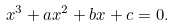Convert formula to latex. <formula><loc_0><loc_0><loc_500><loc_500>x ^ { 3 } + a x ^ { 2 } + b x + c = 0 .</formula> 